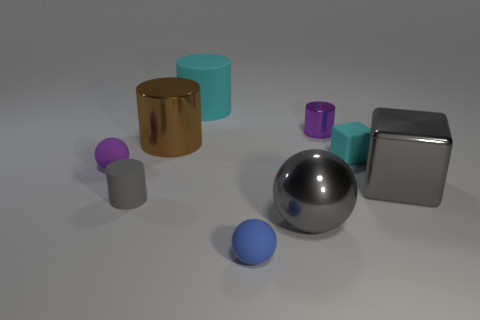Is there a cylinder behind the rubber cylinder that is in front of the purple rubber object?
Keep it short and to the point. Yes. The shiny thing that is the same shape as the blue matte object is what color?
Offer a terse response. Gray. What color is the large cylinder that is the same material as the tiny cyan object?
Ensure brevity in your answer.  Cyan. Is there a small cyan object that is to the left of the gray thing on the right side of the cylinder that is on the right side of the big gray sphere?
Keep it short and to the point. Yes. Is the number of blue spheres to the right of the gray metallic ball less than the number of blocks that are behind the tiny purple ball?
Provide a short and direct response. Yes. What number of big balls have the same material as the small cyan thing?
Provide a succinct answer. 0. Do the gray sphere and the cyan matte thing that is in front of the tiny shiny cylinder have the same size?
Your response must be concise. No. There is a big sphere that is the same color as the large cube; what is it made of?
Your answer should be very brief. Metal. How big is the rubber sphere in front of the large gray object in front of the gray thing left of the big cyan cylinder?
Provide a succinct answer. Small. Are there more tiny cylinders that are behind the small purple rubber thing than big brown metallic cylinders to the left of the large brown cylinder?
Keep it short and to the point. Yes. 